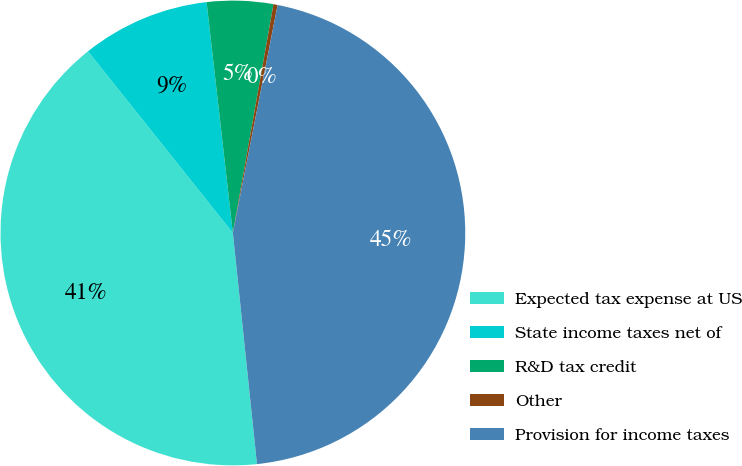Convert chart to OTSL. <chart><loc_0><loc_0><loc_500><loc_500><pie_chart><fcel>Expected tax expense at US<fcel>State income taxes net of<fcel>R&D tax credit<fcel>Other<fcel>Provision for income taxes<nl><fcel>40.94%<fcel>8.91%<fcel>4.6%<fcel>0.29%<fcel>45.26%<nl></chart> 